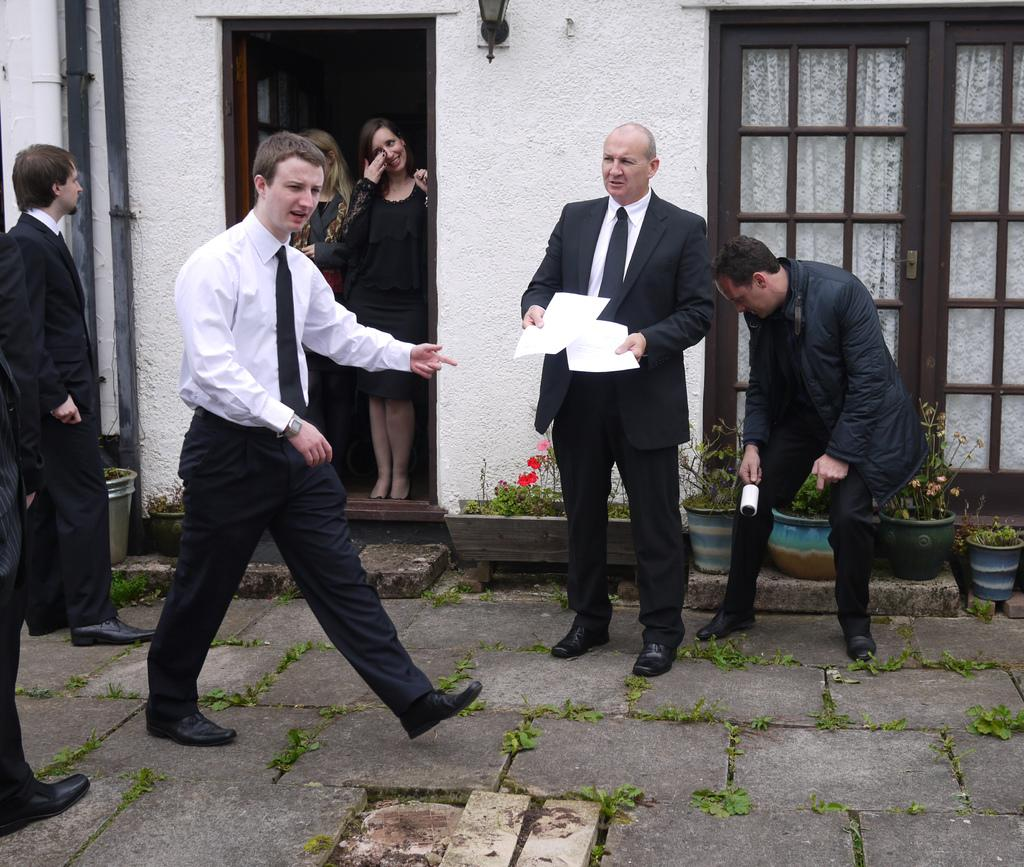How many people are in the image? There are people in the image, but the exact number is not specified. Where are some of the people located in the image? Some people are inside a building in the image. What architectural features can be seen in the image? Poles, windows, and doors are visible in the image. What type of vegetation is present in the image? Grass is present in the image. What objects are used for decoration in the image? Flower pots are visible in the image. Can you tell me how many skates are being used by the people in the image? There is no mention of skates or any similar objects in the image, so it is not possible to determine how many are being used. 